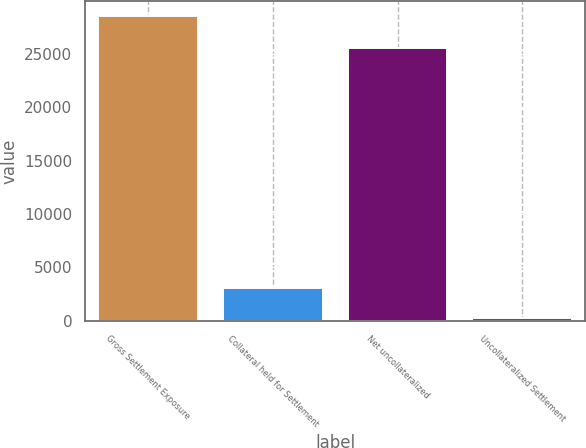Convert chart. <chart><loc_0><loc_0><loc_500><loc_500><bar_chart><fcel>Gross Settlement Exposure<fcel>Collateral held for Settlement<fcel>Net uncollateralized<fcel>Uncollateralized Settlement<nl><fcel>28509<fcel>3096.6<fcel>25516<fcel>273<nl></chart> 